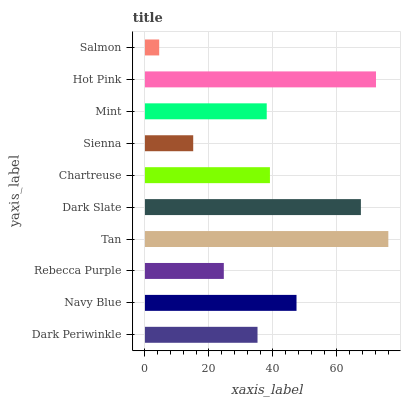Is Salmon the minimum?
Answer yes or no. Yes. Is Tan the maximum?
Answer yes or no. Yes. Is Navy Blue the minimum?
Answer yes or no. No. Is Navy Blue the maximum?
Answer yes or no. No. Is Navy Blue greater than Dark Periwinkle?
Answer yes or no. Yes. Is Dark Periwinkle less than Navy Blue?
Answer yes or no. Yes. Is Dark Periwinkle greater than Navy Blue?
Answer yes or no. No. Is Navy Blue less than Dark Periwinkle?
Answer yes or no. No. Is Chartreuse the high median?
Answer yes or no. Yes. Is Mint the low median?
Answer yes or no. Yes. Is Dark Periwinkle the high median?
Answer yes or no. No. Is Hot Pink the low median?
Answer yes or no. No. 